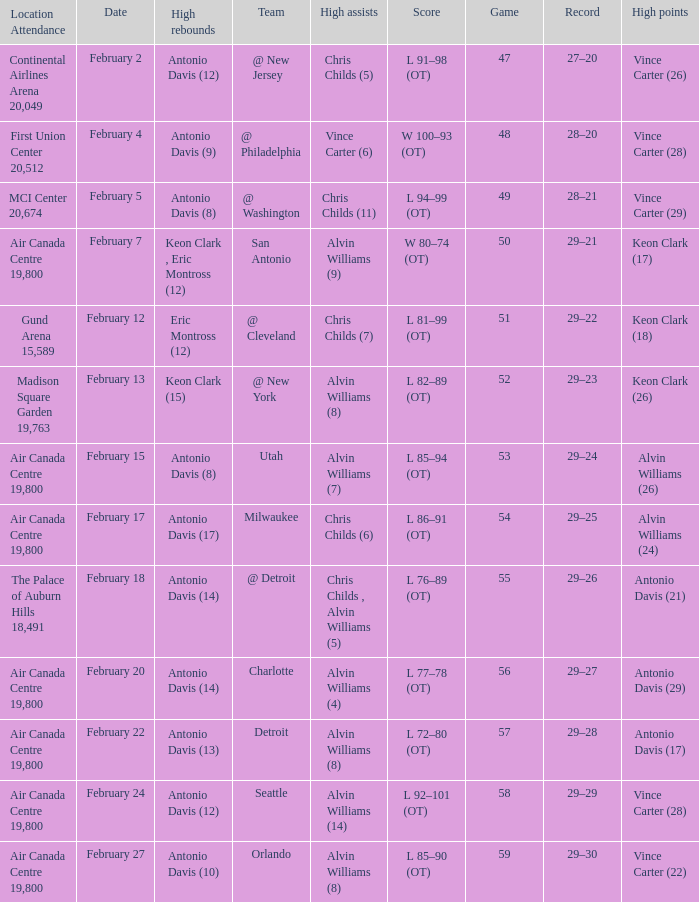What is the Record when the high rebounds was Antonio Davis (9)? 28–20. 